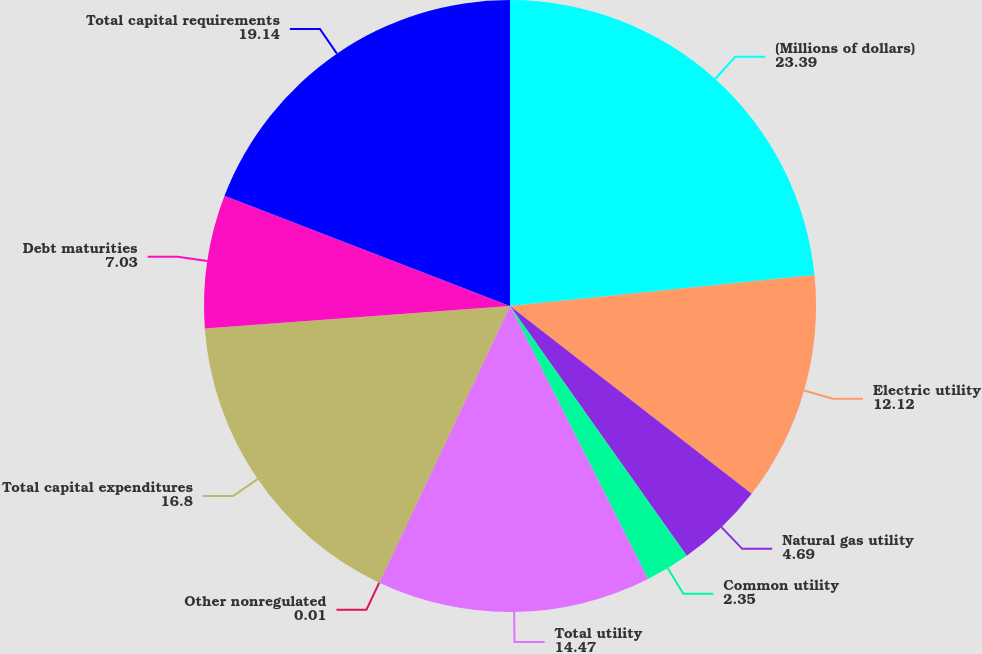<chart> <loc_0><loc_0><loc_500><loc_500><pie_chart><fcel>(Millions of dollars)<fcel>Electric utility<fcel>Natural gas utility<fcel>Common utility<fcel>Total utility<fcel>Other nonregulated<fcel>Total capital expenditures<fcel>Debt maturities<fcel>Total capital requirements<nl><fcel>23.39%<fcel>12.12%<fcel>4.69%<fcel>2.35%<fcel>14.47%<fcel>0.01%<fcel>16.8%<fcel>7.03%<fcel>19.14%<nl></chart> 